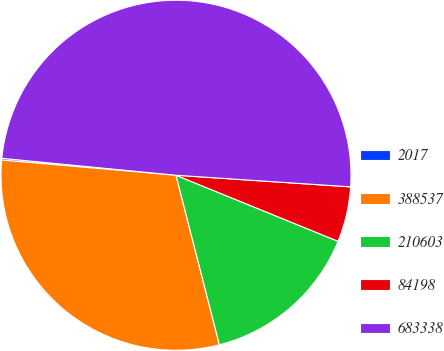Convert chart to OTSL. <chart><loc_0><loc_0><loc_500><loc_500><pie_chart><fcel>2017<fcel>388537<fcel>210603<fcel>84198<fcel>683338<nl><fcel>0.16%<fcel>30.37%<fcel>14.85%<fcel>5.1%<fcel>49.51%<nl></chart> 